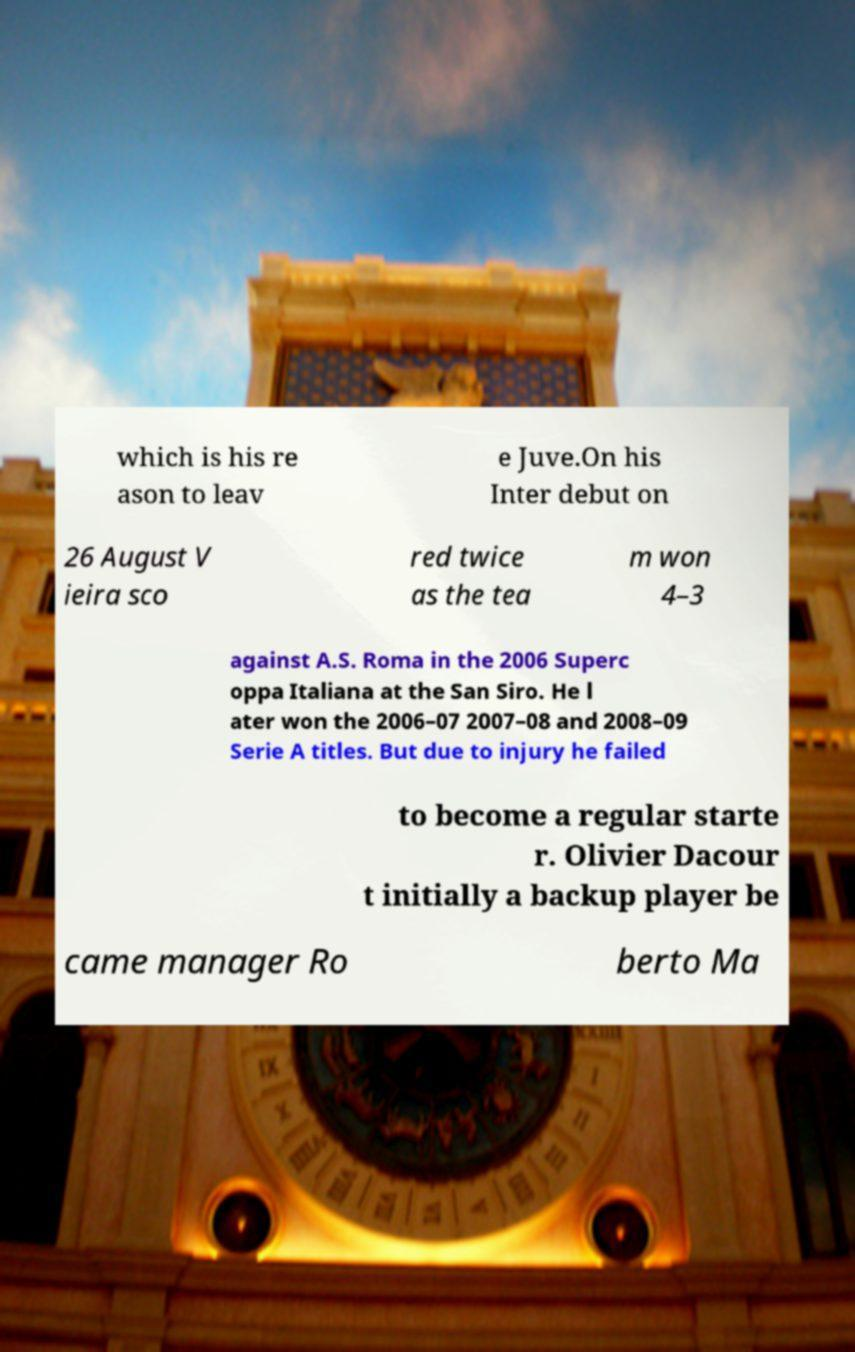What messages or text are displayed in this image? I need them in a readable, typed format. which is his re ason to leav e Juve.On his Inter debut on 26 August V ieira sco red twice as the tea m won 4–3 against A.S. Roma in the 2006 Superc oppa Italiana at the San Siro. He l ater won the 2006–07 2007–08 and 2008–09 Serie A titles. But due to injury he failed to become a regular starte r. Olivier Dacour t initially a backup player be came manager Ro berto Ma 